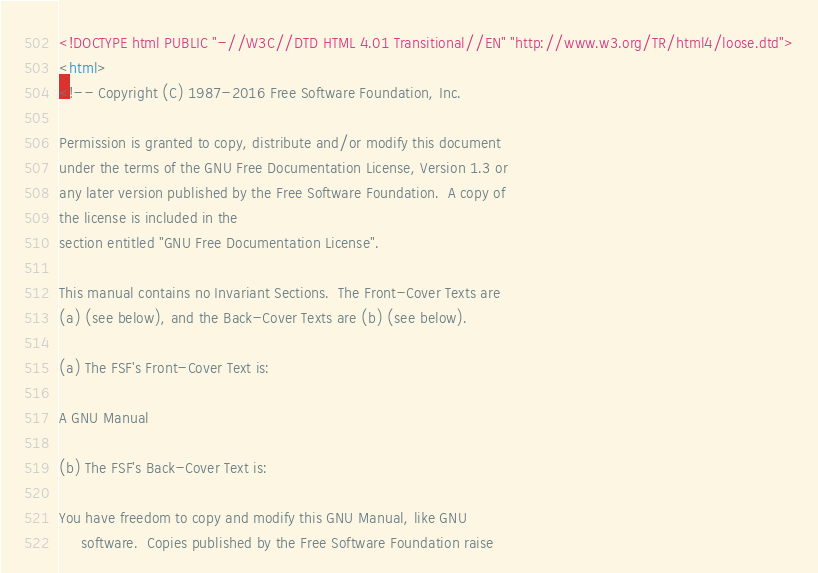Convert code to text. <code><loc_0><loc_0><loc_500><loc_500><_HTML_><!DOCTYPE html PUBLIC "-//W3C//DTD HTML 4.01 Transitional//EN" "http://www.w3.org/TR/html4/loose.dtd">
<html>
<!-- Copyright (C) 1987-2016 Free Software Foundation, Inc.

Permission is granted to copy, distribute and/or modify this document
under the terms of the GNU Free Documentation License, Version 1.3 or
any later version published by the Free Software Foundation.  A copy of
the license is included in the
section entitled "GNU Free Documentation License".

This manual contains no Invariant Sections.  The Front-Cover Texts are
(a) (see below), and the Back-Cover Texts are (b) (see below).

(a) The FSF's Front-Cover Text is:

A GNU Manual

(b) The FSF's Back-Cover Text is:

You have freedom to copy and modify this GNU Manual, like GNU
     software.  Copies published by the Free Software Foundation raise</code> 